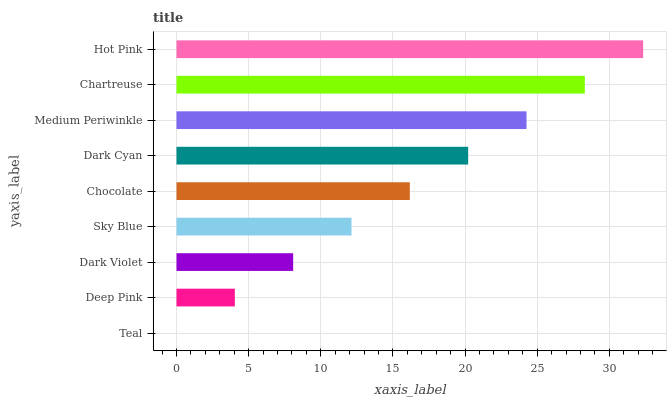Is Teal the minimum?
Answer yes or no. Yes. Is Hot Pink the maximum?
Answer yes or no. Yes. Is Deep Pink the minimum?
Answer yes or no. No. Is Deep Pink the maximum?
Answer yes or no. No. Is Deep Pink greater than Teal?
Answer yes or no. Yes. Is Teal less than Deep Pink?
Answer yes or no. Yes. Is Teal greater than Deep Pink?
Answer yes or no. No. Is Deep Pink less than Teal?
Answer yes or no. No. Is Chocolate the high median?
Answer yes or no. Yes. Is Chocolate the low median?
Answer yes or no. Yes. Is Sky Blue the high median?
Answer yes or no. No. Is Chartreuse the low median?
Answer yes or no. No. 